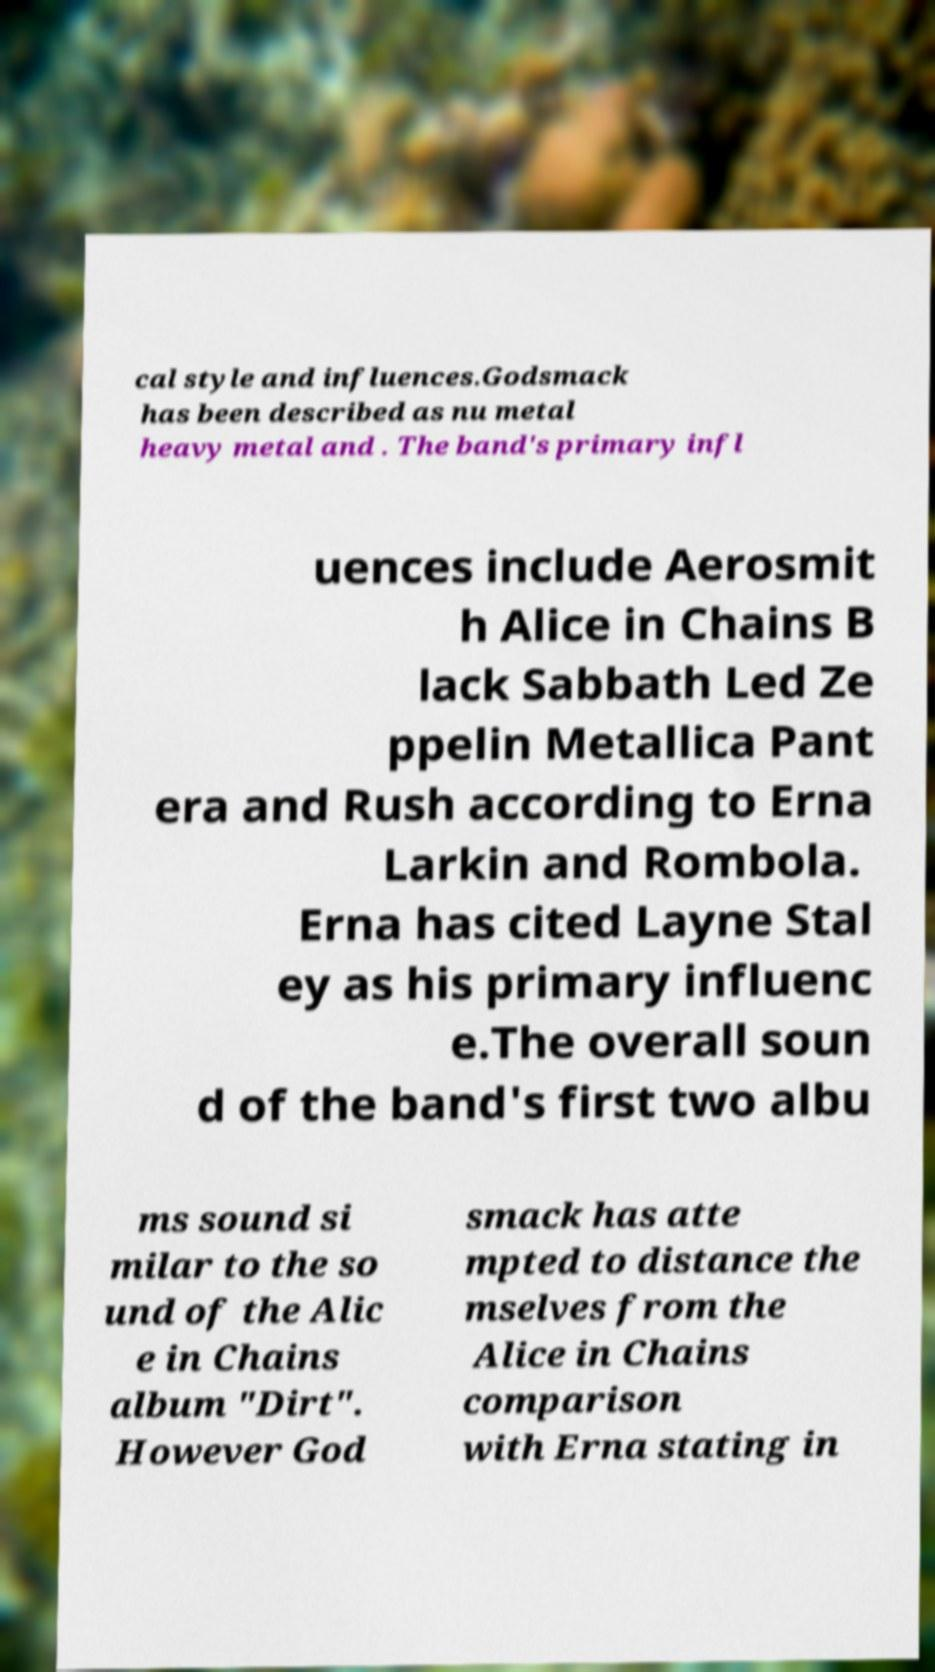For documentation purposes, I need the text within this image transcribed. Could you provide that? cal style and influences.Godsmack has been described as nu metal heavy metal and . The band's primary infl uences include Aerosmit h Alice in Chains B lack Sabbath Led Ze ppelin Metallica Pant era and Rush according to Erna Larkin and Rombola. Erna has cited Layne Stal ey as his primary influenc e.The overall soun d of the band's first two albu ms sound si milar to the so und of the Alic e in Chains album "Dirt". However God smack has atte mpted to distance the mselves from the Alice in Chains comparison with Erna stating in 